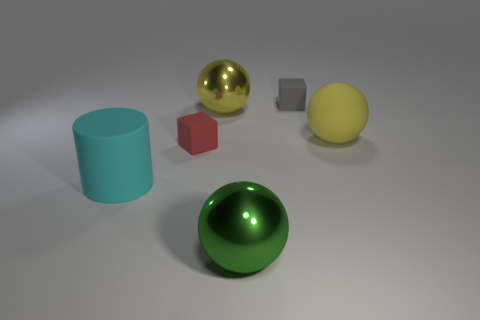Add 3 yellow shiny cylinders. How many objects exist? 9 Subtract all blocks. How many objects are left? 4 Add 4 yellow matte objects. How many yellow matte objects are left? 5 Add 5 green cubes. How many green cubes exist? 5 Subtract 1 green balls. How many objects are left? 5 Subtract all big metal things. Subtract all gray rubber cubes. How many objects are left? 3 